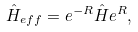Convert formula to latex. <formula><loc_0><loc_0><loc_500><loc_500>\hat { H } _ { e f f } = e ^ { - R } \hat { H } e ^ { R } ,</formula> 